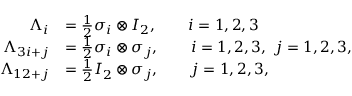Convert formula to latex. <formula><loc_0><loc_0><loc_500><loc_500>\begin{array} { r l } { \Lambda _ { i } } & { = \frac { 1 } { 2 } \sigma _ { i } \otimes I _ { 2 } , \quad i = 1 , 2 , 3 } \\ { \Lambda _ { 3 i + j } } & { = \frac { 1 } { 2 } \sigma _ { i } \otimes \sigma _ { j } , \quad i = 1 , 2 , 3 , \ j = 1 , 2 , 3 , } \\ { \Lambda _ { 1 2 + j } } & { = \frac { 1 } { 2 } I _ { 2 } \otimes \sigma _ { j } , \quad j = 1 , 2 , 3 , } \end{array}</formula> 